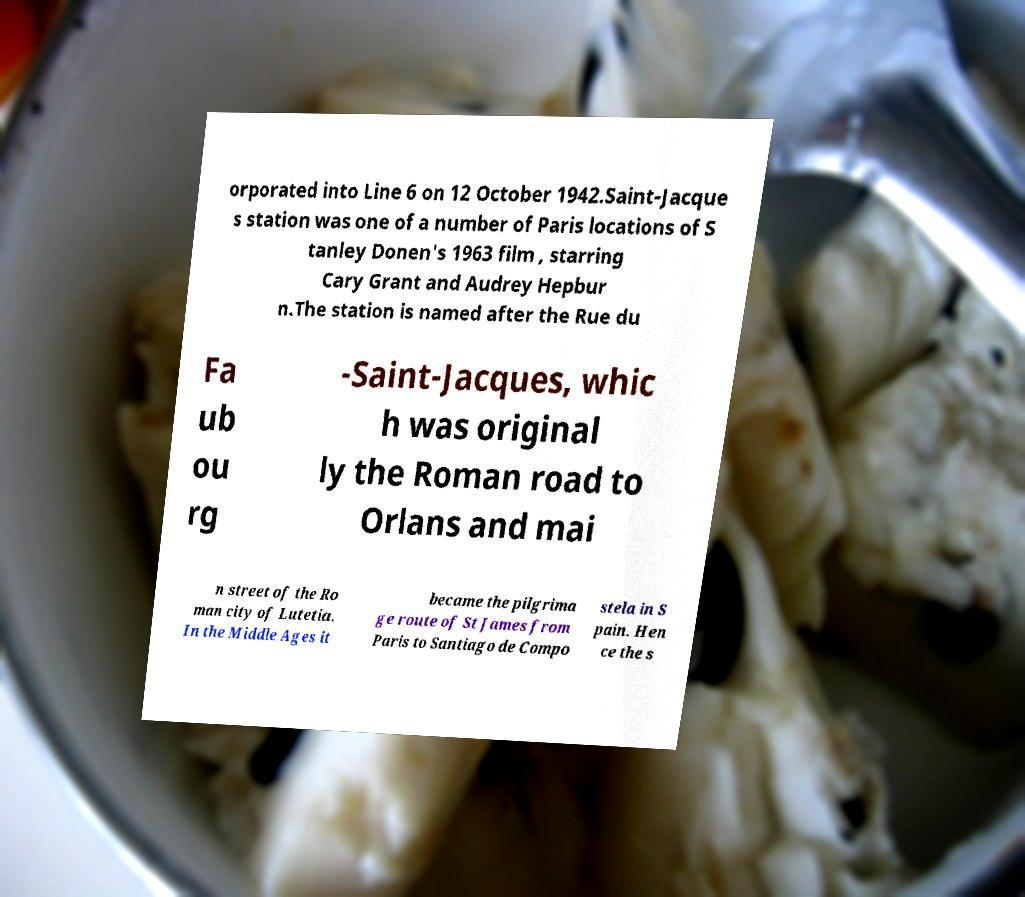Can you accurately transcribe the text from the provided image for me? orporated into Line 6 on 12 October 1942.Saint-Jacque s station was one of a number of Paris locations of S tanley Donen's 1963 film , starring Cary Grant and Audrey Hepbur n.The station is named after the Rue du Fa ub ou rg -Saint-Jacques, whic h was original ly the Roman road to Orlans and mai n street of the Ro man city of Lutetia. In the Middle Ages it became the pilgrima ge route of St James from Paris to Santiago de Compo stela in S pain. Hen ce the s 